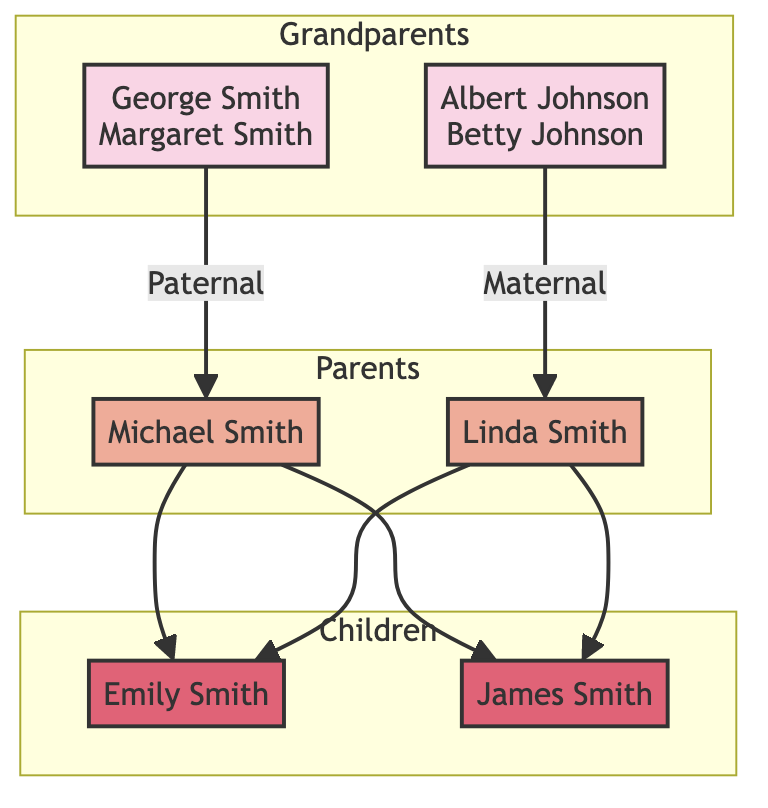What are the names of the paternal grandparents? The diagram shows the paternal grandparents as George Smith and Margaret Smith.
Answer: George Smith, Margaret Smith How many children are there in the family tree? The diagram lists two children: Emily Smith and James Smith. Therefore, the total is two.
Answer: 2 What type of financial support did the paternal grandparents provide? According to the diagram, the paternal grandparents contributed to education funds and provided emergency funds during hardships.
Answer: Contributed to education funds, provided emergency funds What is the emotional well-being impact of the father? The diagram indicates that Michael Smith had a high emotional well-being impact due to his involvement in his children's lives.
Answer: High What decision did Emily Smith make regarding her college education? The diagram states that Emily Smith opted for a local college to stay close to family due to homesickness concerns.
Answer: Opted for local college Which family member explored study abroad but decided against it? The diagram states that James Smith explored studying abroad but ultimately decided against it due to homesickness concerns.
Answer: James Smith What financial decision did the mother make to manage homesickness-related expenses? The diagram indicates that Linda Smith maintained a budget to manage homesickness-related expenses.
Answer: Maintained a budget How did the emotional well-being impacts differ between paternal and maternal grandparents? The paternal grandparents had a high emotional well-being impact due to frequent gatherings, while the maternal grandparents had a moderate impact as they lived in a different city and visited during holidays.
Answer: High, Moderate What financial advice did the maternal grandparents provide? According to the diagram, the maternal grandparents offered investment advice and provided occasional financial gifts.
Answer: Offered investment advice, occasional financial gifts What was the reasoning for the father's decision to purchase a home? The diagram indicates that Michael Smith purchased a home close to grandparents to stay connected with the family, showing the importance of maintaining family ties amidst homesickness.
Answer: To stay connected 